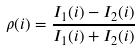<formula> <loc_0><loc_0><loc_500><loc_500>\rho ( i ) = \frac { I _ { 1 } ( i ) - I _ { 2 } ( i ) } { I _ { 1 } ( i ) + I _ { 2 } ( i ) }</formula> 